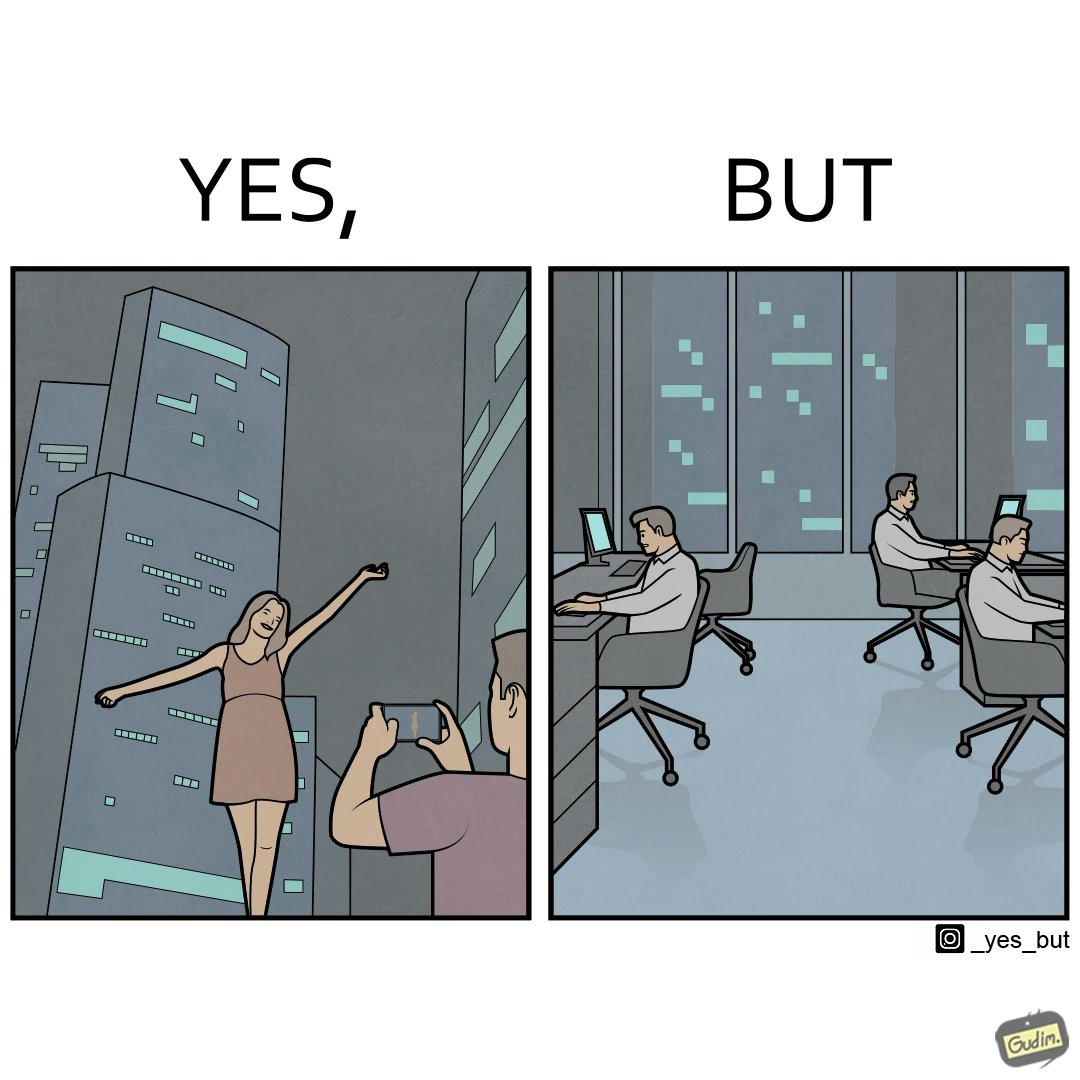What do you see in each half of this image? In the left part of the image: A man taking a woman's photo In the right part of the image: Men working in an office 